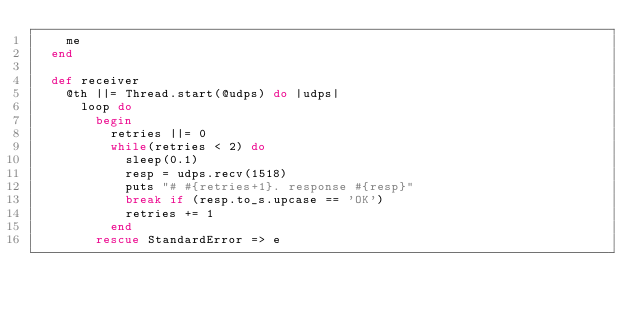Convert code to text. <code><loc_0><loc_0><loc_500><loc_500><_Ruby_>    me 
  end

  def receiver
    @th ||= Thread.start(@udps) do |udps|
      loop do
        begin
          retries ||= 0
          while(retries < 2) do
            sleep(0.1)
            resp = udps.recv(1518)
            puts "# #{retries+1}. response #{resp}"
            break if (resp.to_s.upcase == 'OK')
            retries += 1
          end
        rescue StandardError => e</code> 